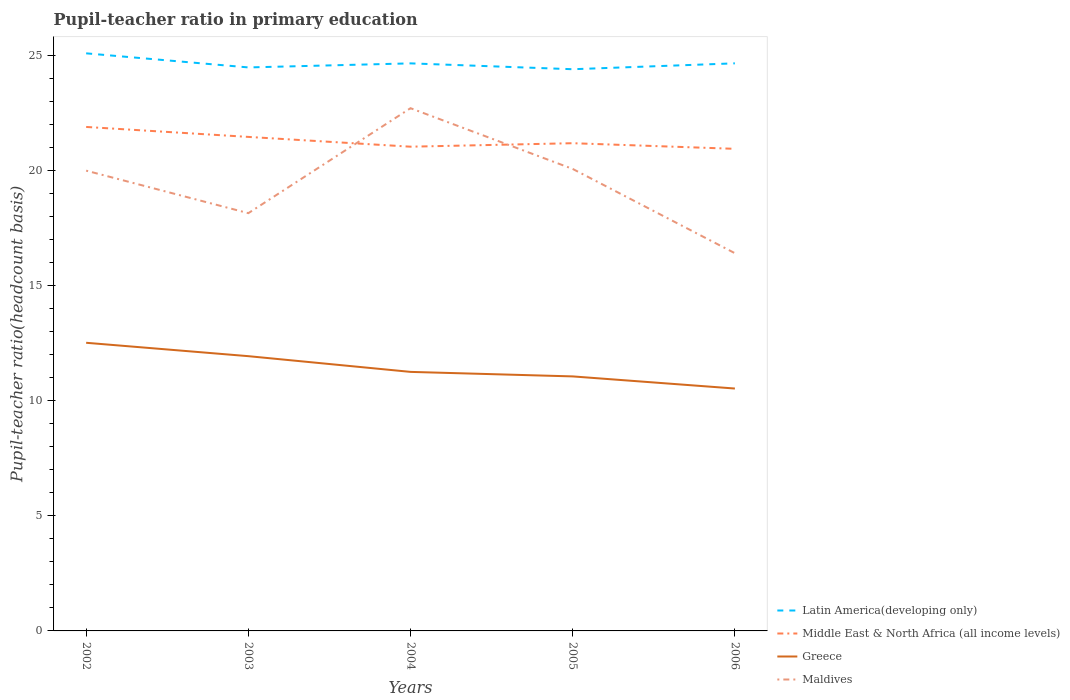How many different coloured lines are there?
Provide a short and direct response. 4. Is the number of lines equal to the number of legend labels?
Offer a very short reply. Yes. Across all years, what is the maximum pupil-teacher ratio in primary education in Latin America(developing only)?
Offer a very short reply. 24.41. In which year was the pupil-teacher ratio in primary education in Maldives maximum?
Your answer should be compact. 2006. What is the total pupil-teacher ratio in primary education in Greece in the graph?
Offer a very short reply. 0.68. What is the difference between the highest and the second highest pupil-teacher ratio in primary education in Middle East & North Africa (all income levels)?
Ensure brevity in your answer.  0.95. What is the difference between the highest and the lowest pupil-teacher ratio in primary education in Latin America(developing only)?
Your answer should be very brief. 2. How many lines are there?
Your response must be concise. 4. How many years are there in the graph?
Offer a very short reply. 5. Are the values on the major ticks of Y-axis written in scientific E-notation?
Provide a short and direct response. No. Does the graph contain grids?
Your answer should be very brief. No. How are the legend labels stacked?
Provide a succinct answer. Vertical. What is the title of the graph?
Offer a very short reply. Pupil-teacher ratio in primary education. Does "Northern Mariana Islands" appear as one of the legend labels in the graph?
Your answer should be compact. No. What is the label or title of the X-axis?
Ensure brevity in your answer.  Years. What is the label or title of the Y-axis?
Your answer should be very brief. Pupil-teacher ratio(headcount basis). What is the Pupil-teacher ratio(headcount basis) in Latin America(developing only) in 2002?
Offer a very short reply. 25.11. What is the Pupil-teacher ratio(headcount basis) in Middle East & North Africa (all income levels) in 2002?
Provide a short and direct response. 21.91. What is the Pupil-teacher ratio(headcount basis) of Greece in 2002?
Ensure brevity in your answer.  12.52. What is the Pupil-teacher ratio(headcount basis) in Maldives in 2002?
Make the answer very short. 20.01. What is the Pupil-teacher ratio(headcount basis) in Latin America(developing only) in 2003?
Offer a very short reply. 24.49. What is the Pupil-teacher ratio(headcount basis) in Middle East & North Africa (all income levels) in 2003?
Ensure brevity in your answer.  21.47. What is the Pupil-teacher ratio(headcount basis) of Greece in 2003?
Provide a succinct answer. 11.94. What is the Pupil-teacher ratio(headcount basis) of Maldives in 2003?
Offer a terse response. 18.16. What is the Pupil-teacher ratio(headcount basis) in Latin America(developing only) in 2004?
Your answer should be compact. 24.67. What is the Pupil-teacher ratio(headcount basis) in Middle East & North Africa (all income levels) in 2004?
Offer a terse response. 21.05. What is the Pupil-teacher ratio(headcount basis) of Greece in 2004?
Your answer should be compact. 11.26. What is the Pupil-teacher ratio(headcount basis) in Maldives in 2004?
Your answer should be very brief. 22.72. What is the Pupil-teacher ratio(headcount basis) of Latin America(developing only) in 2005?
Offer a terse response. 24.41. What is the Pupil-teacher ratio(headcount basis) of Middle East & North Africa (all income levels) in 2005?
Your response must be concise. 21.2. What is the Pupil-teacher ratio(headcount basis) of Greece in 2005?
Ensure brevity in your answer.  11.06. What is the Pupil-teacher ratio(headcount basis) of Maldives in 2005?
Give a very brief answer. 20.08. What is the Pupil-teacher ratio(headcount basis) in Latin America(developing only) in 2006?
Ensure brevity in your answer.  24.67. What is the Pupil-teacher ratio(headcount basis) in Middle East & North Africa (all income levels) in 2006?
Your response must be concise. 20.95. What is the Pupil-teacher ratio(headcount basis) in Greece in 2006?
Your answer should be compact. 10.54. What is the Pupil-teacher ratio(headcount basis) in Maldives in 2006?
Your response must be concise. 16.42. Across all years, what is the maximum Pupil-teacher ratio(headcount basis) of Latin America(developing only)?
Provide a succinct answer. 25.11. Across all years, what is the maximum Pupil-teacher ratio(headcount basis) in Middle East & North Africa (all income levels)?
Offer a very short reply. 21.91. Across all years, what is the maximum Pupil-teacher ratio(headcount basis) of Greece?
Provide a succinct answer. 12.52. Across all years, what is the maximum Pupil-teacher ratio(headcount basis) of Maldives?
Your answer should be very brief. 22.72. Across all years, what is the minimum Pupil-teacher ratio(headcount basis) in Latin America(developing only)?
Provide a succinct answer. 24.41. Across all years, what is the minimum Pupil-teacher ratio(headcount basis) in Middle East & North Africa (all income levels)?
Your answer should be compact. 20.95. Across all years, what is the minimum Pupil-teacher ratio(headcount basis) of Greece?
Offer a very short reply. 10.54. Across all years, what is the minimum Pupil-teacher ratio(headcount basis) of Maldives?
Ensure brevity in your answer.  16.42. What is the total Pupil-teacher ratio(headcount basis) in Latin America(developing only) in the graph?
Offer a very short reply. 123.35. What is the total Pupil-teacher ratio(headcount basis) in Middle East & North Africa (all income levels) in the graph?
Keep it short and to the point. 106.58. What is the total Pupil-teacher ratio(headcount basis) of Greece in the graph?
Offer a terse response. 57.33. What is the total Pupil-teacher ratio(headcount basis) of Maldives in the graph?
Your answer should be compact. 97.38. What is the difference between the Pupil-teacher ratio(headcount basis) of Latin America(developing only) in 2002 and that in 2003?
Offer a very short reply. 0.61. What is the difference between the Pupil-teacher ratio(headcount basis) in Middle East & North Africa (all income levels) in 2002 and that in 2003?
Give a very brief answer. 0.43. What is the difference between the Pupil-teacher ratio(headcount basis) of Greece in 2002 and that in 2003?
Provide a short and direct response. 0.58. What is the difference between the Pupil-teacher ratio(headcount basis) in Maldives in 2002 and that in 2003?
Ensure brevity in your answer.  1.85. What is the difference between the Pupil-teacher ratio(headcount basis) of Latin America(developing only) in 2002 and that in 2004?
Your answer should be very brief. 0.44. What is the difference between the Pupil-teacher ratio(headcount basis) of Middle East & North Africa (all income levels) in 2002 and that in 2004?
Offer a very short reply. 0.86. What is the difference between the Pupil-teacher ratio(headcount basis) of Greece in 2002 and that in 2004?
Offer a very short reply. 1.27. What is the difference between the Pupil-teacher ratio(headcount basis) in Maldives in 2002 and that in 2004?
Keep it short and to the point. -2.71. What is the difference between the Pupil-teacher ratio(headcount basis) of Latin America(developing only) in 2002 and that in 2005?
Offer a very short reply. 0.69. What is the difference between the Pupil-teacher ratio(headcount basis) in Middle East & North Africa (all income levels) in 2002 and that in 2005?
Provide a succinct answer. 0.71. What is the difference between the Pupil-teacher ratio(headcount basis) of Greece in 2002 and that in 2005?
Keep it short and to the point. 1.46. What is the difference between the Pupil-teacher ratio(headcount basis) of Maldives in 2002 and that in 2005?
Give a very brief answer. -0.07. What is the difference between the Pupil-teacher ratio(headcount basis) in Latin America(developing only) in 2002 and that in 2006?
Your response must be concise. 0.43. What is the difference between the Pupil-teacher ratio(headcount basis) in Middle East & North Africa (all income levels) in 2002 and that in 2006?
Offer a terse response. 0.95. What is the difference between the Pupil-teacher ratio(headcount basis) in Greece in 2002 and that in 2006?
Your answer should be very brief. 1.99. What is the difference between the Pupil-teacher ratio(headcount basis) of Maldives in 2002 and that in 2006?
Offer a terse response. 3.59. What is the difference between the Pupil-teacher ratio(headcount basis) of Latin America(developing only) in 2003 and that in 2004?
Give a very brief answer. -0.18. What is the difference between the Pupil-teacher ratio(headcount basis) of Middle East & North Africa (all income levels) in 2003 and that in 2004?
Your answer should be compact. 0.42. What is the difference between the Pupil-teacher ratio(headcount basis) in Greece in 2003 and that in 2004?
Provide a short and direct response. 0.68. What is the difference between the Pupil-teacher ratio(headcount basis) of Maldives in 2003 and that in 2004?
Offer a terse response. -4.56. What is the difference between the Pupil-teacher ratio(headcount basis) in Latin America(developing only) in 2003 and that in 2005?
Provide a succinct answer. 0.08. What is the difference between the Pupil-teacher ratio(headcount basis) in Middle East & North Africa (all income levels) in 2003 and that in 2005?
Make the answer very short. 0.27. What is the difference between the Pupil-teacher ratio(headcount basis) of Greece in 2003 and that in 2005?
Your answer should be compact. 0.88. What is the difference between the Pupil-teacher ratio(headcount basis) of Maldives in 2003 and that in 2005?
Give a very brief answer. -1.92. What is the difference between the Pupil-teacher ratio(headcount basis) in Latin America(developing only) in 2003 and that in 2006?
Provide a short and direct response. -0.18. What is the difference between the Pupil-teacher ratio(headcount basis) of Middle East & North Africa (all income levels) in 2003 and that in 2006?
Make the answer very short. 0.52. What is the difference between the Pupil-teacher ratio(headcount basis) of Greece in 2003 and that in 2006?
Give a very brief answer. 1.41. What is the difference between the Pupil-teacher ratio(headcount basis) in Maldives in 2003 and that in 2006?
Your response must be concise. 1.74. What is the difference between the Pupil-teacher ratio(headcount basis) of Latin America(developing only) in 2004 and that in 2005?
Keep it short and to the point. 0.25. What is the difference between the Pupil-teacher ratio(headcount basis) of Middle East & North Africa (all income levels) in 2004 and that in 2005?
Provide a succinct answer. -0.15. What is the difference between the Pupil-teacher ratio(headcount basis) in Greece in 2004 and that in 2005?
Keep it short and to the point. 0.2. What is the difference between the Pupil-teacher ratio(headcount basis) of Maldives in 2004 and that in 2005?
Ensure brevity in your answer.  2.64. What is the difference between the Pupil-teacher ratio(headcount basis) of Latin America(developing only) in 2004 and that in 2006?
Your answer should be compact. -0. What is the difference between the Pupil-teacher ratio(headcount basis) in Middle East & North Africa (all income levels) in 2004 and that in 2006?
Give a very brief answer. 0.09. What is the difference between the Pupil-teacher ratio(headcount basis) of Greece in 2004 and that in 2006?
Keep it short and to the point. 0.72. What is the difference between the Pupil-teacher ratio(headcount basis) in Maldives in 2004 and that in 2006?
Make the answer very short. 6.3. What is the difference between the Pupil-teacher ratio(headcount basis) of Latin America(developing only) in 2005 and that in 2006?
Give a very brief answer. -0.26. What is the difference between the Pupil-teacher ratio(headcount basis) in Middle East & North Africa (all income levels) in 2005 and that in 2006?
Your answer should be compact. 0.24. What is the difference between the Pupil-teacher ratio(headcount basis) of Greece in 2005 and that in 2006?
Offer a terse response. 0.53. What is the difference between the Pupil-teacher ratio(headcount basis) in Maldives in 2005 and that in 2006?
Make the answer very short. 3.66. What is the difference between the Pupil-teacher ratio(headcount basis) of Latin America(developing only) in 2002 and the Pupil-teacher ratio(headcount basis) of Middle East & North Africa (all income levels) in 2003?
Give a very brief answer. 3.63. What is the difference between the Pupil-teacher ratio(headcount basis) in Latin America(developing only) in 2002 and the Pupil-teacher ratio(headcount basis) in Greece in 2003?
Your response must be concise. 13.16. What is the difference between the Pupil-teacher ratio(headcount basis) in Latin America(developing only) in 2002 and the Pupil-teacher ratio(headcount basis) in Maldives in 2003?
Offer a terse response. 6.95. What is the difference between the Pupil-teacher ratio(headcount basis) of Middle East & North Africa (all income levels) in 2002 and the Pupil-teacher ratio(headcount basis) of Greece in 2003?
Offer a terse response. 9.96. What is the difference between the Pupil-teacher ratio(headcount basis) of Middle East & North Africa (all income levels) in 2002 and the Pupil-teacher ratio(headcount basis) of Maldives in 2003?
Give a very brief answer. 3.75. What is the difference between the Pupil-teacher ratio(headcount basis) in Greece in 2002 and the Pupil-teacher ratio(headcount basis) in Maldives in 2003?
Provide a succinct answer. -5.63. What is the difference between the Pupil-teacher ratio(headcount basis) in Latin America(developing only) in 2002 and the Pupil-teacher ratio(headcount basis) in Middle East & North Africa (all income levels) in 2004?
Provide a succinct answer. 4.06. What is the difference between the Pupil-teacher ratio(headcount basis) in Latin America(developing only) in 2002 and the Pupil-teacher ratio(headcount basis) in Greece in 2004?
Make the answer very short. 13.85. What is the difference between the Pupil-teacher ratio(headcount basis) in Latin America(developing only) in 2002 and the Pupil-teacher ratio(headcount basis) in Maldives in 2004?
Offer a very short reply. 2.38. What is the difference between the Pupil-teacher ratio(headcount basis) in Middle East & North Africa (all income levels) in 2002 and the Pupil-teacher ratio(headcount basis) in Greece in 2004?
Your answer should be compact. 10.65. What is the difference between the Pupil-teacher ratio(headcount basis) in Middle East & North Africa (all income levels) in 2002 and the Pupil-teacher ratio(headcount basis) in Maldives in 2004?
Your answer should be compact. -0.81. What is the difference between the Pupil-teacher ratio(headcount basis) in Greece in 2002 and the Pupil-teacher ratio(headcount basis) in Maldives in 2004?
Give a very brief answer. -10.2. What is the difference between the Pupil-teacher ratio(headcount basis) in Latin America(developing only) in 2002 and the Pupil-teacher ratio(headcount basis) in Middle East & North Africa (all income levels) in 2005?
Give a very brief answer. 3.91. What is the difference between the Pupil-teacher ratio(headcount basis) in Latin America(developing only) in 2002 and the Pupil-teacher ratio(headcount basis) in Greece in 2005?
Your answer should be very brief. 14.04. What is the difference between the Pupil-teacher ratio(headcount basis) in Latin America(developing only) in 2002 and the Pupil-teacher ratio(headcount basis) in Maldives in 2005?
Make the answer very short. 5.02. What is the difference between the Pupil-teacher ratio(headcount basis) of Middle East & North Africa (all income levels) in 2002 and the Pupil-teacher ratio(headcount basis) of Greece in 2005?
Make the answer very short. 10.84. What is the difference between the Pupil-teacher ratio(headcount basis) of Middle East & North Africa (all income levels) in 2002 and the Pupil-teacher ratio(headcount basis) of Maldives in 2005?
Offer a very short reply. 1.83. What is the difference between the Pupil-teacher ratio(headcount basis) of Greece in 2002 and the Pupil-teacher ratio(headcount basis) of Maldives in 2005?
Ensure brevity in your answer.  -7.56. What is the difference between the Pupil-teacher ratio(headcount basis) of Latin America(developing only) in 2002 and the Pupil-teacher ratio(headcount basis) of Middle East & North Africa (all income levels) in 2006?
Provide a short and direct response. 4.15. What is the difference between the Pupil-teacher ratio(headcount basis) in Latin America(developing only) in 2002 and the Pupil-teacher ratio(headcount basis) in Greece in 2006?
Offer a terse response. 14.57. What is the difference between the Pupil-teacher ratio(headcount basis) in Latin America(developing only) in 2002 and the Pupil-teacher ratio(headcount basis) in Maldives in 2006?
Make the answer very short. 8.69. What is the difference between the Pupil-teacher ratio(headcount basis) of Middle East & North Africa (all income levels) in 2002 and the Pupil-teacher ratio(headcount basis) of Greece in 2006?
Offer a terse response. 11.37. What is the difference between the Pupil-teacher ratio(headcount basis) of Middle East & North Africa (all income levels) in 2002 and the Pupil-teacher ratio(headcount basis) of Maldives in 2006?
Offer a very short reply. 5.49. What is the difference between the Pupil-teacher ratio(headcount basis) of Greece in 2002 and the Pupil-teacher ratio(headcount basis) of Maldives in 2006?
Ensure brevity in your answer.  -3.89. What is the difference between the Pupil-teacher ratio(headcount basis) of Latin America(developing only) in 2003 and the Pupil-teacher ratio(headcount basis) of Middle East & North Africa (all income levels) in 2004?
Offer a very short reply. 3.45. What is the difference between the Pupil-teacher ratio(headcount basis) in Latin America(developing only) in 2003 and the Pupil-teacher ratio(headcount basis) in Greece in 2004?
Offer a very short reply. 13.23. What is the difference between the Pupil-teacher ratio(headcount basis) of Latin America(developing only) in 2003 and the Pupil-teacher ratio(headcount basis) of Maldives in 2004?
Your answer should be very brief. 1.77. What is the difference between the Pupil-teacher ratio(headcount basis) of Middle East & North Africa (all income levels) in 2003 and the Pupil-teacher ratio(headcount basis) of Greece in 2004?
Give a very brief answer. 10.21. What is the difference between the Pupil-teacher ratio(headcount basis) of Middle East & North Africa (all income levels) in 2003 and the Pupil-teacher ratio(headcount basis) of Maldives in 2004?
Your answer should be very brief. -1.25. What is the difference between the Pupil-teacher ratio(headcount basis) of Greece in 2003 and the Pupil-teacher ratio(headcount basis) of Maldives in 2004?
Provide a short and direct response. -10.78. What is the difference between the Pupil-teacher ratio(headcount basis) in Latin America(developing only) in 2003 and the Pupil-teacher ratio(headcount basis) in Middle East & North Africa (all income levels) in 2005?
Provide a short and direct response. 3.29. What is the difference between the Pupil-teacher ratio(headcount basis) in Latin America(developing only) in 2003 and the Pupil-teacher ratio(headcount basis) in Greece in 2005?
Your answer should be compact. 13.43. What is the difference between the Pupil-teacher ratio(headcount basis) in Latin America(developing only) in 2003 and the Pupil-teacher ratio(headcount basis) in Maldives in 2005?
Your response must be concise. 4.41. What is the difference between the Pupil-teacher ratio(headcount basis) in Middle East & North Africa (all income levels) in 2003 and the Pupil-teacher ratio(headcount basis) in Greece in 2005?
Provide a succinct answer. 10.41. What is the difference between the Pupil-teacher ratio(headcount basis) in Middle East & North Africa (all income levels) in 2003 and the Pupil-teacher ratio(headcount basis) in Maldives in 2005?
Keep it short and to the point. 1.39. What is the difference between the Pupil-teacher ratio(headcount basis) in Greece in 2003 and the Pupil-teacher ratio(headcount basis) in Maldives in 2005?
Offer a very short reply. -8.14. What is the difference between the Pupil-teacher ratio(headcount basis) of Latin America(developing only) in 2003 and the Pupil-teacher ratio(headcount basis) of Middle East & North Africa (all income levels) in 2006?
Ensure brevity in your answer.  3.54. What is the difference between the Pupil-teacher ratio(headcount basis) of Latin America(developing only) in 2003 and the Pupil-teacher ratio(headcount basis) of Greece in 2006?
Provide a short and direct response. 13.96. What is the difference between the Pupil-teacher ratio(headcount basis) in Latin America(developing only) in 2003 and the Pupil-teacher ratio(headcount basis) in Maldives in 2006?
Provide a short and direct response. 8.08. What is the difference between the Pupil-teacher ratio(headcount basis) of Middle East & North Africa (all income levels) in 2003 and the Pupil-teacher ratio(headcount basis) of Greece in 2006?
Ensure brevity in your answer.  10.94. What is the difference between the Pupil-teacher ratio(headcount basis) of Middle East & North Africa (all income levels) in 2003 and the Pupil-teacher ratio(headcount basis) of Maldives in 2006?
Your response must be concise. 5.05. What is the difference between the Pupil-teacher ratio(headcount basis) in Greece in 2003 and the Pupil-teacher ratio(headcount basis) in Maldives in 2006?
Make the answer very short. -4.48. What is the difference between the Pupil-teacher ratio(headcount basis) of Latin America(developing only) in 2004 and the Pupil-teacher ratio(headcount basis) of Middle East & North Africa (all income levels) in 2005?
Offer a terse response. 3.47. What is the difference between the Pupil-teacher ratio(headcount basis) in Latin America(developing only) in 2004 and the Pupil-teacher ratio(headcount basis) in Greece in 2005?
Provide a succinct answer. 13.61. What is the difference between the Pupil-teacher ratio(headcount basis) of Latin America(developing only) in 2004 and the Pupil-teacher ratio(headcount basis) of Maldives in 2005?
Keep it short and to the point. 4.59. What is the difference between the Pupil-teacher ratio(headcount basis) in Middle East & North Africa (all income levels) in 2004 and the Pupil-teacher ratio(headcount basis) in Greece in 2005?
Provide a succinct answer. 9.98. What is the difference between the Pupil-teacher ratio(headcount basis) of Middle East & North Africa (all income levels) in 2004 and the Pupil-teacher ratio(headcount basis) of Maldives in 2005?
Ensure brevity in your answer.  0.97. What is the difference between the Pupil-teacher ratio(headcount basis) in Greece in 2004 and the Pupil-teacher ratio(headcount basis) in Maldives in 2005?
Your answer should be compact. -8.82. What is the difference between the Pupil-teacher ratio(headcount basis) of Latin America(developing only) in 2004 and the Pupil-teacher ratio(headcount basis) of Middle East & North Africa (all income levels) in 2006?
Offer a very short reply. 3.71. What is the difference between the Pupil-teacher ratio(headcount basis) of Latin America(developing only) in 2004 and the Pupil-teacher ratio(headcount basis) of Greece in 2006?
Provide a short and direct response. 14.13. What is the difference between the Pupil-teacher ratio(headcount basis) of Latin America(developing only) in 2004 and the Pupil-teacher ratio(headcount basis) of Maldives in 2006?
Your answer should be very brief. 8.25. What is the difference between the Pupil-teacher ratio(headcount basis) of Middle East & North Africa (all income levels) in 2004 and the Pupil-teacher ratio(headcount basis) of Greece in 2006?
Your answer should be compact. 10.51. What is the difference between the Pupil-teacher ratio(headcount basis) of Middle East & North Africa (all income levels) in 2004 and the Pupil-teacher ratio(headcount basis) of Maldives in 2006?
Give a very brief answer. 4.63. What is the difference between the Pupil-teacher ratio(headcount basis) in Greece in 2004 and the Pupil-teacher ratio(headcount basis) in Maldives in 2006?
Your answer should be very brief. -5.16. What is the difference between the Pupil-teacher ratio(headcount basis) in Latin America(developing only) in 2005 and the Pupil-teacher ratio(headcount basis) in Middle East & North Africa (all income levels) in 2006?
Offer a very short reply. 3.46. What is the difference between the Pupil-teacher ratio(headcount basis) of Latin America(developing only) in 2005 and the Pupil-teacher ratio(headcount basis) of Greece in 2006?
Your answer should be compact. 13.88. What is the difference between the Pupil-teacher ratio(headcount basis) in Latin America(developing only) in 2005 and the Pupil-teacher ratio(headcount basis) in Maldives in 2006?
Your answer should be compact. 8. What is the difference between the Pupil-teacher ratio(headcount basis) in Middle East & North Africa (all income levels) in 2005 and the Pupil-teacher ratio(headcount basis) in Greece in 2006?
Offer a very short reply. 10.66. What is the difference between the Pupil-teacher ratio(headcount basis) of Middle East & North Africa (all income levels) in 2005 and the Pupil-teacher ratio(headcount basis) of Maldives in 2006?
Give a very brief answer. 4.78. What is the difference between the Pupil-teacher ratio(headcount basis) of Greece in 2005 and the Pupil-teacher ratio(headcount basis) of Maldives in 2006?
Your response must be concise. -5.36. What is the average Pupil-teacher ratio(headcount basis) of Latin America(developing only) per year?
Make the answer very short. 24.67. What is the average Pupil-teacher ratio(headcount basis) of Middle East & North Africa (all income levels) per year?
Your answer should be compact. 21.32. What is the average Pupil-teacher ratio(headcount basis) of Greece per year?
Offer a very short reply. 11.46. What is the average Pupil-teacher ratio(headcount basis) of Maldives per year?
Make the answer very short. 19.48. In the year 2002, what is the difference between the Pupil-teacher ratio(headcount basis) of Latin America(developing only) and Pupil-teacher ratio(headcount basis) of Middle East & North Africa (all income levels)?
Give a very brief answer. 3.2. In the year 2002, what is the difference between the Pupil-teacher ratio(headcount basis) in Latin America(developing only) and Pupil-teacher ratio(headcount basis) in Greece?
Offer a very short reply. 12.58. In the year 2002, what is the difference between the Pupil-teacher ratio(headcount basis) in Latin America(developing only) and Pupil-teacher ratio(headcount basis) in Maldives?
Keep it short and to the point. 5.1. In the year 2002, what is the difference between the Pupil-teacher ratio(headcount basis) of Middle East & North Africa (all income levels) and Pupil-teacher ratio(headcount basis) of Greece?
Your answer should be compact. 9.38. In the year 2002, what is the difference between the Pupil-teacher ratio(headcount basis) of Middle East & North Africa (all income levels) and Pupil-teacher ratio(headcount basis) of Maldives?
Offer a terse response. 1.9. In the year 2002, what is the difference between the Pupil-teacher ratio(headcount basis) in Greece and Pupil-teacher ratio(headcount basis) in Maldives?
Offer a very short reply. -7.48. In the year 2003, what is the difference between the Pupil-teacher ratio(headcount basis) in Latin America(developing only) and Pupil-teacher ratio(headcount basis) in Middle East & North Africa (all income levels)?
Provide a short and direct response. 3.02. In the year 2003, what is the difference between the Pupil-teacher ratio(headcount basis) of Latin America(developing only) and Pupil-teacher ratio(headcount basis) of Greece?
Your answer should be very brief. 12.55. In the year 2003, what is the difference between the Pupil-teacher ratio(headcount basis) of Latin America(developing only) and Pupil-teacher ratio(headcount basis) of Maldives?
Your answer should be very brief. 6.33. In the year 2003, what is the difference between the Pupil-teacher ratio(headcount basis) of Middle East & North Africa (all income levels) and Pupil-teacher ratio(headcount basis) of Greece?
Ensure brevity in your answer.  9.53. In the year 2003, what is the difference between the Pupil-teacher ratio(headcount basis) of Middle East & North Africa (all income levels) and Pupil-teacher ratio(headcount basis) of Maldives?
Give a very brief answer. 3.31. In the year 2003, what is the difference between the Pupil-teacher ratio(headcount basis) in Greece and Pupil-teacher ratio(headcount basis) in Maldives?
Provide a short and direct response. -6.22. In the year 2004, what is the difference between the Pupil-teacher ratio(headcount basis) in Latin America(developing only) and Pupil-teacher ratio(headcount basis) in Middle East & North Africa (all income levels)?
Your response must be concise. 3.62. In the year 2004, what is the difference between the Pupil-teacher ratio(headcount basis) of Latin America(developing only) and Pupil-teacher ratio(headcount basis) of Greece?
Your answer should be very brief. 13.41. In the year 2004, what is the difference between the Pupil-teacher ratio(headcount basis) of Latin America(developing only) and Pupil-teacher ratio(headcount basis) of Maldives?
Make the answer very short. 1.95. In the year 2004, what is the difference between the Pupil-teacher ratio(headcount basis) in Middle East & North Africa (all income levels) and Pupil-teacher ratio(headcount basis) in Greece?
Offer a terse response. 9.79. In the year 2004, what is the difference between the Pupil-teacher ratio(headcount basis) in Middle East & North Africa (all income levels) and Pupil-teacher ratio(headcount basis) in Maldives?
Offer a very short reply. -1.67. In the year 2004, what is the difference between the Pupil-teacher ratio(headcount basis) of Greece and Pupil-teacher ratio(headcount basis) of Maldives?
Your response must be concise. -11.46. In the year 2005, what is the difference between the Pupil-teacher ratio(headcount basis) of Latin America(developing only) and Pupil-teacher ratio(headcount basis) of Middle East & North Africa (all income levels)?
Your answer should be compact. 3.22. In the year 2005, what is the difference between the Pupil-teacher ratio(headcount basis) in Latin America(developing only) and Pupil-teacher ratio(headcount basis) in Greece?
Provide a short and direct response. 13.35. In the year 2005, what is the difference between the Pupil-teacher ratio(headcount basis) of Latin America(developing only) and Pupil-teacher ratio(headcount basis) of Maldives?
Keep it short and to the point. 4.33. In the year 2005, what is the difference between the Pupil-teacher ratio(headcount basis) in Middle East & North Africa (all income levels) and Pupil-teacher ratio(headcount basis) in Greece?
Offer a very short reply. 10.14. In the year 2005, what is the difference between the Pupil-teacher ratio(headcount basis) of Middle East & North Africa (all income levels) and Pupil-teacher ratio(headcount basis) of Maldives?
Provide a succinct answer. 1.12. In the year 2005, what is the difference between the Pupil-teacher ratio(headcount basis) in Greece and Pupil-teacher ratio(headcount basis) in Maldives?
Your answer should be compact. -9.02. In the year 2006, what is the difference between the Pupil-teacher ratio(headcount basis) in Latin America(developing only) and Pupil-teacher ratio(headcount basis) in Middle East & North Africa (all income levels)?
Offer a very short reply. 3.72. In the year 2006, what is the difference between the Pupil-teacher ratio(headcount basis) in Latin America(developing only) and Pupil-teacher ratio(headcount basis) in Greece?
Your answer should be very brief. 14.13. In the year 2006, what is the difference between the Pupil-teacher ratio(headcount basis) of Latin America(developing only) and Pupil-teacher ratio(headcount basis) of Maldives?
Your answer should be compact. 8.25. In the year 2006, what is the difference between the Pupil-teacher ratio(headcount basis) of Middle East & North Africa (all income levels) and Pupil-teacher ratio(headcount basis) of Greece?
Provide a short and direct response. 10.42. In the year 2006, what is the difference between the Pupil-teacher ratio(headcount basis) of Middle East & North Africa (all income levels) and Pupil-teacher ratio(headcount basis) of Maldives?
Your answer should be compact. 4.54. In the year 2006, what is the difference between the Pupil-teacher ratio(headcount basis) in Greece and Pupil-teacher ratio(headcount basis) in Maldives?
Your response must be concise. -5.88. What is the ratio of the Pupil-teacher ratio(headcount basis) of Middle East & North Africa (all income levels) in 2002 to that in 2003?
Provide a succinct answer. 1.02. What is the ratio of the Pupil-teacher ratio(headcount basis) in Greece in 2002 to that in 2003?
Your answer should be very brief. 1.05. What is the ratio of the Pupil-teacher ratio(headcount basis) of Maldives in 2002 to that in 2003?
Provide a succinct answer. 1.1. What is the ratio of the Pupil-teacher ratio(headcount basis) in Latin America(developing only) in 2002 to that in 2004?
Your answer should be compact. 1.02. What is the ratio of the Pupil-teacher ratio(headcount basis) of Middle East & North Africa (all income levels) in 2002 to that in 2004?
Keep it short and to the point. 1.04. What is the ratio of the Pupil-teacher ratio(headcount basis) of Greece in 2002 to that in 2004?
Keep it short and to the point. 1.11. What is the ratio of the Pupil-teacher ratio(headcount basis) of Maldives in 2002 to that in 2004?
Give a very brief answer. 0.88. What is the ratio of the Pupil-teacher ratio(headcount basis) of Latin America(developing only) in 2002 to that in 2005?
Make the answer very short. 1.03. What is the ratio of the Pupil-teacher ratio(headcount basis) of Middle East & North Africa (all income levels) in 2002 to that in 2005?
Your response must be concise. 1.03. What is the ratio of the Pupil-teacher ratio(headcount basis) of Greece in 2002 to that in 2005?
Offer a terse response. 1.13. What is the ratio of the Pupil-teacher ratio(headcount basis) in Latin America(developing only) in 2002 to that in 2006?
Provide a succinct answer. 1.02. What is the ratio of the Pupil-teacher ratio(headcount basis) in Middle East & North Africa (all income levels) in 2002 to that in 2006?
Offer a terse response. 1.05. What is the ratio of the Pupil-teacher ratio(headcount basis) of Greece in 2002 to that in 2006?
Make the answer very short. 1.19. What is the ratio of the Pupil-teacher ratio(headcount basis) of Maldives in 2002 to that in 2006?
Make the answer very short. 1.22. What is the ratio of the Pupil-teacher ratio(headcount basis) in Latin America(developing only) in 2003 to that in 2004?
Your answer should be very brief. 0.99. What is the ratio of the Pupil-teacher ratio(headcount basis) in Middle East & North Africa (all income levels) in 2003 to that in 2004?
Your answer should be very brief. 1.02. What is the ratio of the Pupil-teacher ratio(headcount basis) in Greece in 2003 to that in 2004?
Offer a terse response. 1.06. What is the ratio of the Pupil-teacher ratio(headcount basis) in Maldives in 2003 to that in 2004?
Ensure brevity in your answer.  0.8. What is the ratio of the Pupil-teacher ratio(headcount basis) in Middle East & North Africa (all income levels) in 2003 to that in 2005?
Give a very brief answer. 1.01. What is the ratio of the Pupil-teacher ratio(headcount basis) in Greece in 2003 to that in 2005?
Offer a very short reply. 1.08. What is the ratio of the Pupil-teacher ratio(headcount basis) of Maldives in 2003 to that in 2005?
Your answer should be very brief. 0.9. What is the ratio of the Pupil-teacher ratio(headcount basis) of Latin America(developing only) in 2003 to that in 2006?
Give a very brief answer. 0.99. What is the ratio of the Pupil-teacher ratio(headcount basis) in Middle East & North Africa (all income levels) in 2003 to that in 2006?
Offer a very short reply. 1.02. What is the ratio of the Pupil-teacher ratio(headcount basis) of Greece in 2003 to that in 2006?
Provide a succinct answer. 1.13. What is the ratio of the Pupil-teacher ratio(headcount basis) of Maldives in 2003 to that in 2006?
Your response must be concise. 1.11. What is the ratio of the Pupil-teacher ratio(headcount basis) in Latin America(developing only) in 2004 to that in 2005?
Your answer should be very brief. 1.01. What is the ratio of the Pupil-teacher ratio(headcount basis) in Middle East & North Africa (all income levels) in 2004 to that in 2005?
Provide a succinct answer. 0.99. What is the ratio of the Pupil-teacher ratio(headcount basis) in Greece in 2004 to that in 2005?
Offer a very short reply. 1.02. What is the ratio of the Pupil-teacher ratio(headcount basis) in Maldives in 2004 to that in 2005?
Offer a terse response. 1.13. What is the ratio of the Pupil-teacher ratio(headcount basis) of Latin America(developing only) in 2004 to that in 2006?
Offer a very short reply. 1. What is the ratio of the Pupil-teacher ratio(headcount basis) of Greece in 2004 to that in 2006?
Your answer should be very brief. 1.07. What is the ratio of the Pupil-teacher ratio(headcount basis) in Maldives in 2004 to that in 2006?
Provide a succinct answer. 1.38. What is the ratio of the Pupil-teacher ratio(headcount basis) of Middle East & North Africa (all income levels) in 2005 to that in 2006?
Your answer should be very brief. 1.01. What is the ratio of the Pupil-teacher ratio(headcount basis) of Maldives in 2005 to that in 2006?
Offer a terse response. 1.22. What is the difference between the highest and the second highest Pupil-teacher ratio(headcount basis) of Latin America(developing only)?
Your answer should be very brief. 0.43. What is the difference between the highest and the second highest Pupil-teacher ratio(headcount basis) of Middle East & North Africa (all income levels)?
Provide a short and direct response. 0.43. What is the difference between the highest and the second highest Pupil-teacher ratio(headcount basis) in Greece?
Provide a short and direct response. 0.58. What is the difference between the highest and the second highest Pupil-teacher ratio(headcount basis) in Maldives?
Your answer should be compact. 2.64. What is the difference between the highest and the lowest Pupil-teacher ratio(headcount basis) in Latin America(developing only)?
Your answer should be very brief. 0.69. What is the difference between the highest and the lowest Pupil-teacher ratio(headcount basis) in Middle East & North Africa (all income levels)?
Your response must be concise. 0.95. What is the difference between the highest and the lowest Pupil-teacher ratio(headcount basis) in Greece?
Give a very brief answer. 1.99. What is the difference between the highest and the lowest Pupil-teacher ratio(headcount basis) in Maldives?
Give a very brief answer. 6.3. 